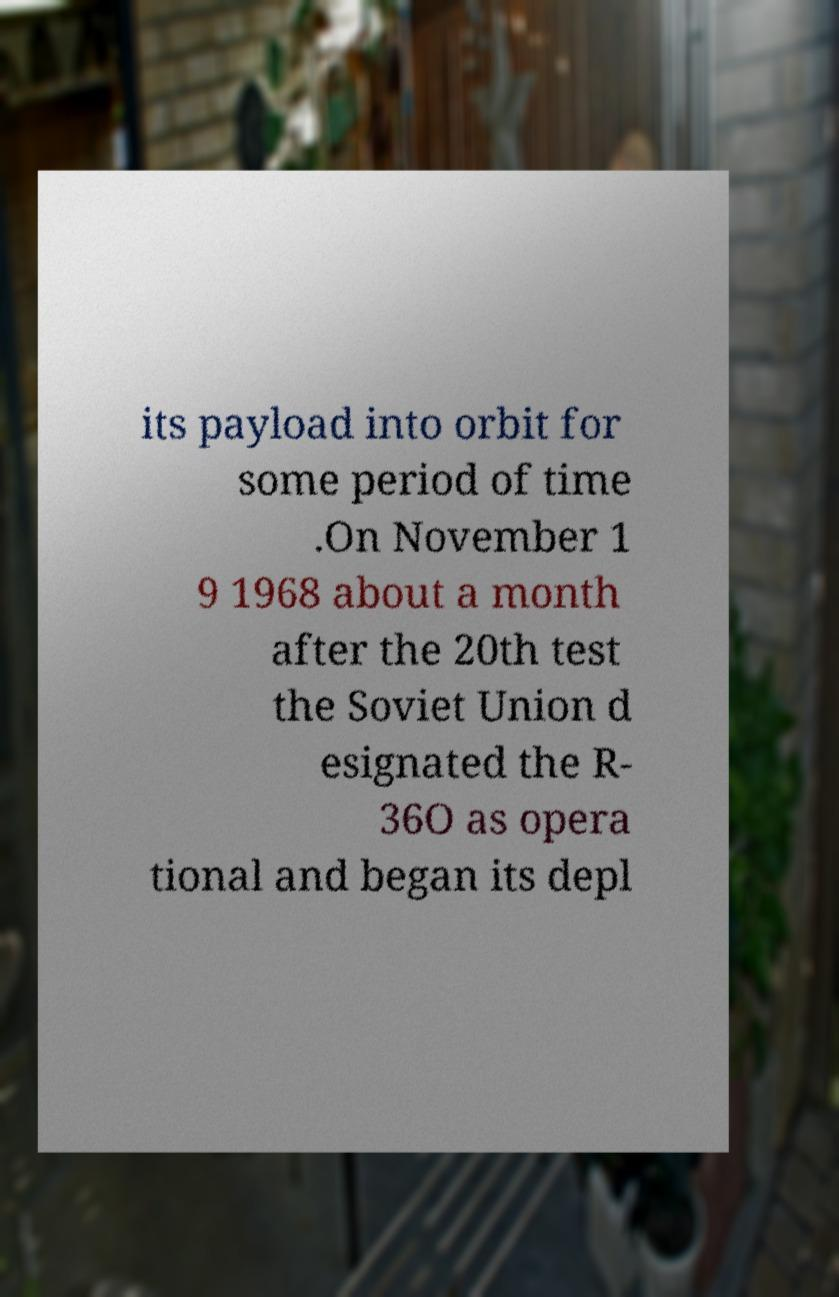Can you accurately transcribe the text from the provided image for me? its payload into orbit for some period of time .On November 1 9 1968 about a month after the 20th test the Soviet Union d esignated the R- 36O as opera tional and began its depl 